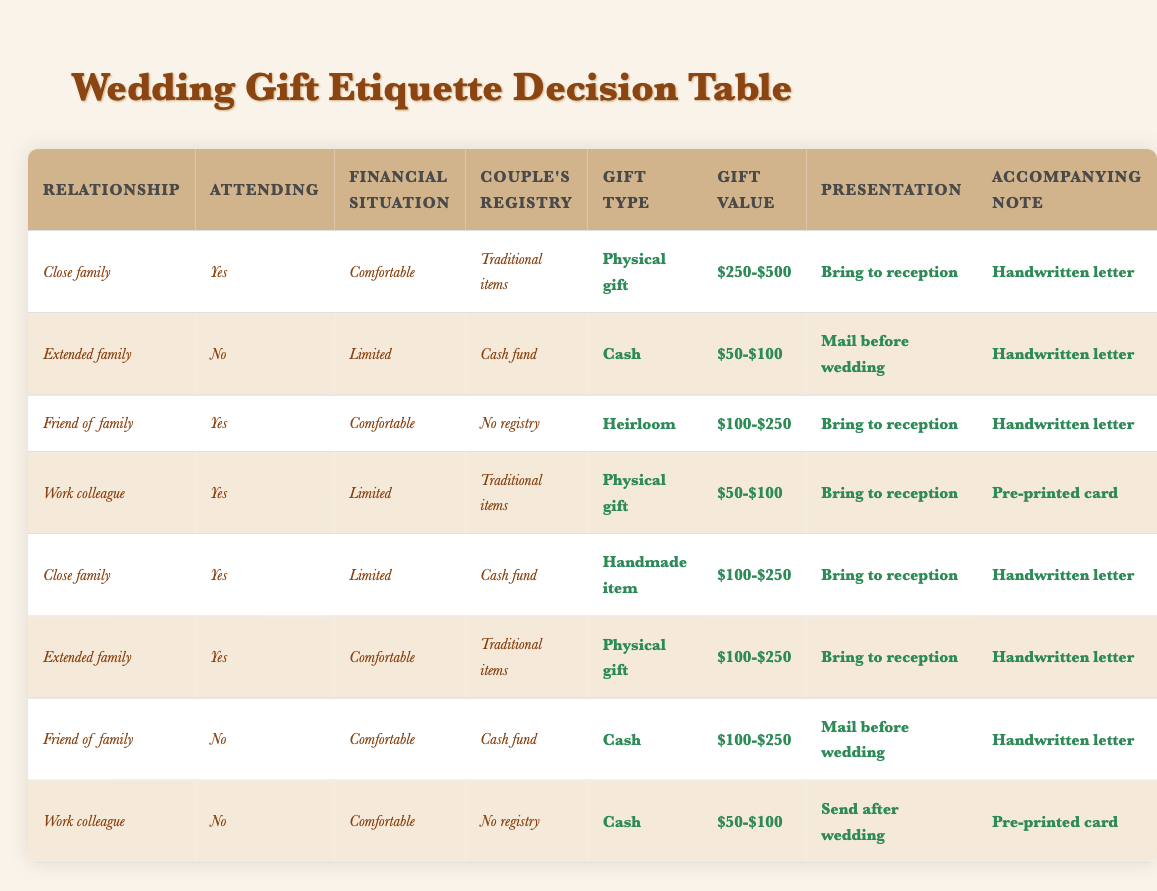What type of gift should a close family member who can attend the wedding and is comfortable financially choose? According to the table, a close family member who can attend the wedding and has a comfortable financial situation should choose a physical gift, valued between $250 and $500, present it at the reception, and include a handwritten letter.
Answer: Physical gift, $250-$500, Bring to reception, Handwritten letter If I am attending the wedding as a friend of the family but have a limited financial situation, what should I do? In the table, there is no row that specifically matches a friend of the family who can attend but has limited finances, so the answer cannot be directly derived. However, for friends of the family in general, they may choose an heirloom gift at $100-$250 if conditions align.
Answer: No specific answer found Should a work colleague send a gift after the wedding? The table states that if a work colleague cannot attend and has a comfortable financial situation, they should send cash valued between $50 and $100 after the wedding with a pre-printed card.
Answer: Yes What is the gift value range for an extended family member attending the wedding and having a comfortable financial situation? The relevant row indicates that an extended family member attending the wedding and having a comfortable financial situation would choose a physical gift valued between $100 and $250, to be brought to the reception, along with a handwritten letter.
Answer: $100-$250 Are handmade gifts acceptable for limited financial situations? Yes, based on the table, a close family member in a limited financial situation choosing a cash fund can opt for a handmade item valued between $100 and $250. They should bring it to the reception and include a handwritten note.
Answer: Yes What is the maximum gift value suggested for a work colleague who cannot attend and has a comfortable financial situation with no registry? According to the table, a work colleague who cannot attend and has a comfortable financial situation with no registry should send cash valued between $50 and $100 after the wedding, using a pre-printed card. The maximum suggested gift value is therefore $100.
Answer: $100 Which family relationship has the option for gifting an heirloom and what conditions must be met? A friend of the family has the option to gift an heirloom. They must be attending the wedding with a comfortable financial situation and no registry in place, which allows them to choose this type of gift valued between $100 and $250.
Answer: Friend of the family, Yes, Comfortable, No registry Is there any situation where a cash gift is preferred for limited financial situations? Yes, the table shows that an extended family member who cannot attend the wedding and has a limited financial situation should send cash valued between $50 and $100 before the wedding, accompanied by a handwritten letter.
Answer: Yes 